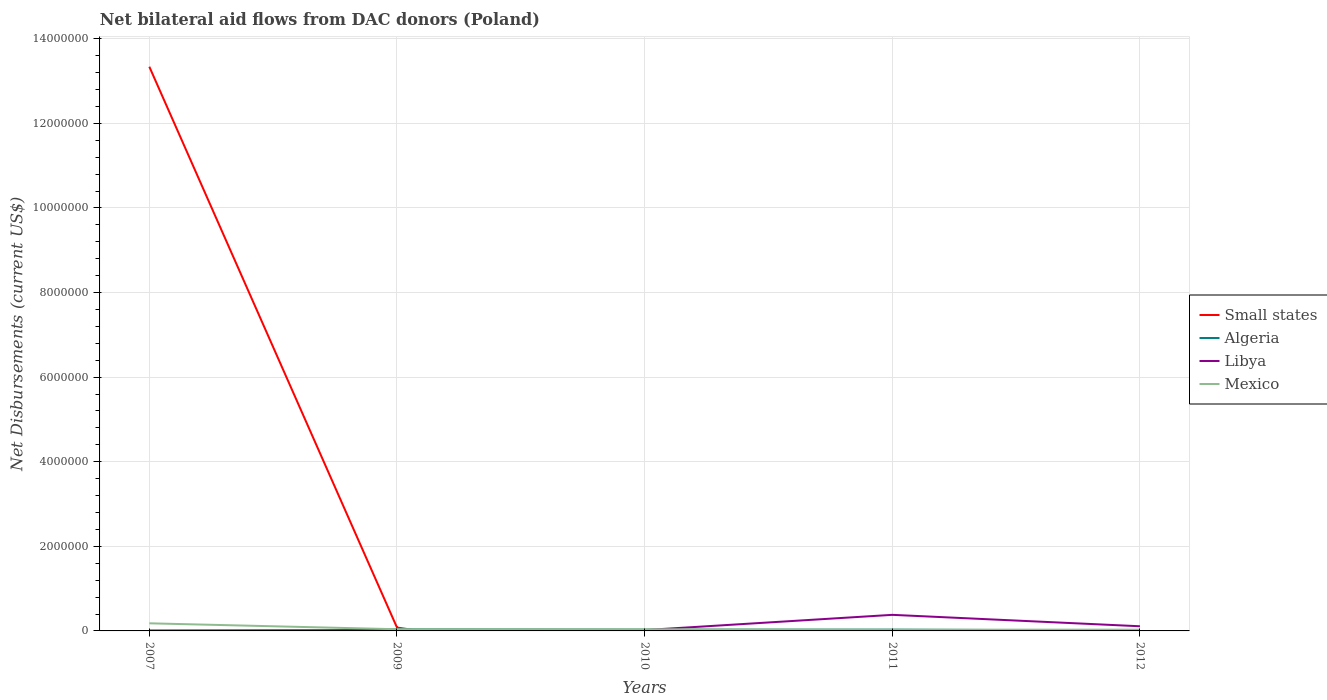How many different coloured lines are there?
Make the answer very short. 4. Does the line corresponding to Mexico intersect with the line corresponding to Algeria?
Your response must be concise. Yes. Is the number of lines equal to the number of legend labels?
Keep it short and to the point. No. Across all years, what is the maximum net bilateral aid flows in Algeria?
Your response must be concise. 0. What is the total net bilateral aid flows in Mexico in the graph?
Offer a very short reply. 0. What is the difference between the highest and the second highest net bilateral aid flows in Mexico?
Ensure brevity in your answer.  1.50e+05. How many lines are there?
Your answer should be compact. 4. What is the difference between two consecutive major ticks on the Y-axis?
Your answer should be very brief. 2.00e+06. Does the graph contain grids?
Your response must be concise. Yes. How many legend labels are there?
Provide a short and direct response. 4. What is the title of the graph?
Your response must be concise. Net bilateral aid flows from DAC donors (Poland). What is the label or title of the X-axis?
Make the answer very short. Years. What is the label or title of the Y-axis?
Ensure brevity in your answer.  Net Disbursements (current US$). What is the Net Disbursements (current US$) in Small states in 2007?
Your answer should be very brief. 1.33e+07. What is the Net Disbursements (current US$) in Algeria in 2007?
Make the answer very short. 0. What is the Net Disbursements (current US$) in Libya in 2007?
Offer a very short reply. 10000. What is the Net Disbursements (current US$) in Libya in 2009?
Your answer should be very brief. 2.00e+04. What is the Net Disbursements (current US$) of Mexico in 2009?
Offer a very short reply. 4.00e+04. What is the Net Disbursements (current US$) in Algeria in 2010?
Give a very brief answer. 3.00e+04. What is the Net Disbursements (current US$) in Libya in 2011?
Offer a terse response. 3.80e+05. What is the Net Disbursements (current US$) of Small states in 2012?
Provide a short and direct response. 0. What is the Net Disbursements (current US$) of Libya in 2012?
Your answer should be very brief. 1.10e+05. Across all years, what is the maximum Net Disbursements (current US$) in Small states?
Your answer should be very brief. 1.33e+07. Across all years, what is the minimum Net Disbursements (current US$) in Algeria?
Make the answer very short. 0. Across all years, what is the minimum Net Disbursements (current US$) in Mexico?
Keep it short and to the point. 3.00e+04. What is the total Net Disbursements (current US$) of Small states in the graph?
Offer a very short reply. 1.34e+07. What is the total Net Disbursements (current US$) of Libya in the graph?
Make the answer very short. 5.40e+05. What is the difference between the Net Disbursements (current US$) in Small states in 2007 and that in 2009?
Ensure brevity in your answer.  1.33e+07. What is the difference between the Net Disbursements (current US$) of Libya in 2007 and that in 2010?
Provide a short and direct response. -10000. What is the difference between the Net Disbursements (current US$) in Mexico in 2007 and that in 2010?
Ensure brevity in your answer.  1.40e+05. What is the difference between the Net Disbursements (current US$) in Libya in 2007 and that in 2011?
Give a very brief answer. -3.70e+05. What is the difference between the Net Disbursements (current US$) of Mexico in 2007 and that in 2012?
Provide a short and direct response. 1.50e+05. What is the difference between the Net Disbursements (current US$) in Algeria in 2009 and that in 2010?
Offer a terse response. 10000. What is the difference between the Net Disbursements (current US$) in Mexico in 2009 and that in 2010?
Give a very brief answer. 0. What is the difference between the Net Disbursements (current US$) in Libya in 2009 and that in 2011?
Ensure brevity in your answer.  -3.60e+05. What is the difference between the Net Disbursements (current US$) in Algeria in 2009 and that in 2012?
Provide a short and direct response. 3.00e+04. What is the difference between the Net Disbursements (current US$) in Libya in 2009 and that in 2012?
Ensure brevity in your answer.  -9.00e+04. What is the difference between the Net Disbursements (current US$) of Mexico in 2009 and that in 2012?
Provide a succinct answer. 10000. What is the difference between the Net Disbursements (current US$) of Algeria in 2010 and that in 2011?
Offer a terse response. 0. What is the difference between the Net Disbursements (current US$) of Libya in 2010 and that in 2011?
Ensure brevity in your answer.  -3.60e+05. What is the difference between the Net Disbursements (current US$) in Mexico in 2011 and that in 2012?
Your response must be concise. 0. What is the difference between the Net Disbursements (current US$) in Small states in 2007 and the Net Disbursements (current US$) in Algeria in 2009?
Offer a terse response. 1.33e+07. What is the difference between the Net Disbursements (current US$) in Small states in 2007 and the Net Disbursements (current US$) in Libya in 2009?
Provide a succinct answer. 1.33e+07. What is the difference between the Net Disbursements (current US$) of Small states in 2007 and the Net Disbursements (current US$) of Mexico in 2009?
Provide a succinct answer. 1.33e+07. What is the difference between the Net Disbursements (current US$) in Small states in 2007 and the Net Disbursements (current US$) in Algeria in 2010?
Provide a short and direct response. 1.33e+07. What is the difference between the Net Disbursements (current US$) of Small states in 2007 and the Net Disbursements (current US$) of Libya in 2010?
Ensure brevity in your answer.  1.33e+07. What is the difference between the Net Disbursements (current US$) of Small states in 2007 and the Net Disbursements (current US$) of Mexico in 2010?
Offer a terse response. 1.33e+07. What is the difference between the Net Disbursements (current US$) of Libya in 2007 and the Net Disbursements (current US$) of Mexico in 2010?
Your response must be concise. -3.00e+04. What is the difference between the Net Disbursements (current US$) of Small states in 2007 and the Net Disbursements (current US$) of Algeria in 2011?
Your answer should be very brief. 1.33e+07. What is the difference between the Net Disbursements (current US$) in Small states in 2007 and the Net Disbursements (current US$) in Libya in 2011?
Ensure brevity in your answer.  1.30e+07. What is the difference between the Net Disbursements (current US$) in Small states in 2007 and the Net Disbursements (current US$) in Mexico in 2011?
Your answer should be compact. 1.33e+07. What is the difference between the Net Disbursements (current US$) of Libya in 2007 and the Net Disbursements (current US$) of Mexico in 2011?
Your response must be concise. -2.00e+04. What is the difference between the Net Disbursements (current US$) in Small states in 2007 and the Net Disbursements (current US$) in Algeria in 2012?
Your response must be concise. 1.33e+07. What is the difference between the Net Disbursements (current US$) in Small states in 2007 and the Net Disbursements (current US$) in Libya in 2012?
Offer a very short reply. 1.32e+07. What is the difference between the Net Disbursements (current US$) in Small states in 2007 and the Net Disbursements (current US$) in Mexico in 2012?
Ensure brevity in your answer.  1.33e+07. What is the difference between the Net Disbursements (current US$) of Small states in 2009 and the Net Disbursements (current US$) of Mexico in 2010?
Offer a very short reply. 4.00e+04. What is the difference between the Net Disbursements (current US$) in Small states in 2009 and the Net Disbursements (current US$) in Algeria in 2011?
Ensure brevity in your answer.  5.00e+04. What is the difference between the Net Disbursements (current US$) of Small states in 2009 and the Net Disbursements (current US$) of Mexico in 2011?
Offer a very short reply. 5.00e+04. What is the difference between the Net Disbursements (current US$) of Small states in 2009 and the Net Disbursements (current US$) of Algeria in 2012?
Provide a succinct answer. 7.00e+04. What is the difference between the Net Disbursements (current US$) in Small states in 2009 and the Net Disbursements (current US$) in Libya in 2012?
Your answer should be very brief. -3.00e+04. What is the difference between the Net Disbursements (current US$) in Algeria in 2009 and the Net Disbursements (current US$) in Libya in 2012?
Ensure brevity in your answer.  -7.00e+04. What is the difference between the Net Disbursements (current US$) in Libya in 2009 and the Net Disbursements (current US$) in Mexico in 2012?
Provide a short and direct response. -10000. What is the difference between the Net Disbursements (current US$) of Algeria in 2010 and the Net Disbursements (current US$) of Libya in 2011?
Offer a terse response. -3.50e+05. What is the difference between the Net Disbursements (current US$) of Libya in 2010 and the Net Disbursements (current US$) of Mexico in 2011?
Your answer should be compact. -10000. What is the difference between the Net Disbursements (current US$) in Libya in 2010 and the Net Disbursements (current US$) in Mexico in 2012?
Offer a terse response. -10000. What is the difference between the Net Disbursements (current US$) of Algeria in 2011 and the Net Disbursements (current US$) of Libya in 2012?
Your answer should be compact. -8.00e+04. What is the difference between the Net Disbursements (current US$) in Algeria in 2011 and the Net Disbursements (current US$) in Mexico in 2012?
Your answer should be compact. 0. What is the difference between the Net Disbursements (current US$) of Libya in 2011 and the Net Disbursements (current US$) of Mexico in 2012?
Ensure brevity in your answer.  3.50e+05. What is the average Net Disbursements (current US$) in Small states per year?
Your answer should be very brief. 2.68e+06. What is the average Net Disbursements (current US$) in Algeria per year?
Make the answer very short. 2.20e+04. What is the average Net Disbursements (current US$) in Libya per year?
Make the answer very short. 1.08e+05. What is the average Net Disbursements (current US$) in Mexico per year?
Your answer should be compact. 6.40e+04. In the year 2007, what is the difference between the Net Disbursements (current US$) in Small states and Net Disbursements (current US$) in Libya?
Offer a very short reply. 1.33e+07. In the year 2007, what is the difference between the Net Disbursements (current US$) of Small states and Net Disbursements (current US$) of Mexico?
Your answer should be very brief. 1.32e+07. In the year 2007, what is the difference between the Net Disbursements (current US$) of Libya and Net Disbursements (current US$) of Mexico?
Make the answer very short. -1.70e+05. In the year 2009, what is the difference between the Net Disbursements (current US$) in Small states and Net Disbursements (current US$) in Libya?
Your answer should be very brief. 6.00e+04. In the year 2009, what is the difference between the Net Disbursements (current US$) in Small states and Net Disbursements (current US$) in Mexico?
Offer a terse response. 4.00e+04. In the year 2009, what is the difference between the Net Disbursements (current US$) in Algeria and Net Disbursements (current US$) in Libya?
Offer a very short reply. 2.00e+04. In the year 2009, what is the difference between the Net Disbursements (current US$) of Libya and Net Disbursements (current US$) of Mexico?
Make the answer very short. -2.00e+04. In the year 2010, what is the difference between the Net Disbursements (current US$) in Algeria and Net Disbursements (current US$) in Libya?
Give a very brief answer. 10000. In the year 2011, what is the difference between the Net Disbursements (current US$) of Algeria and Net Disbursements (current US$) of Libya?
Keep it short and to the point. -3.50e+05. What is the ratio of the Net Disbursements (current US$) in Small states in 2007 to that in 2009?
Make the answer very short. 166.75. What is the ratio of the Net Disbursements (current US$) of Mexico in 2007 to that in 2009?
Offer a very short reply. 4.5. What is the ratio of the Net Disbursements (current US$) of Mexico in 2007 to that in 2010?
Ensure brevity in your answer.  4.5. What is the ratio of the Net Disbursements (current US$) in Libya in 2007 to that in 2011?
Your answer should be compact. 0.03. What is the ratio of the Net Disbursements (current US$) of Mexico in 2007 to that in 2011?
Offer a very short reply. 6. What is the ratio of the Net Disbursements (current US$) of Libya in 2007 to that in 2012?
Ensure brevity in your answer.  0.09. What is the ratio of the Net Disbursements (current US$) in Algeria in 2009 to that in 2010?
Offer a terse response. 1.33. What is the ratio of the Net Disbursements (current US$) of Libya in 2009 to that in 2010?
Your answer should be compact. 1. What is the ratio of the Net Disbursements (current US$) in Libya in 2009 to that in 2011?
Your response must be concise. 0.05. What is the ratio of the Net Disbursements (current US$) in Mexico in 2009 to that in 2011?
Your answer should be very brief. 1.33. What is the ratio of the Net Disbursements (current US$) in Libya in 2009 to that in 2012?
Ensure brevity in your answer.  0.18. What is the ratio of the Net Disbursements (current US$) of Mexico in 2009 to that in 2012?
Provide a short and direct response. 1.33. What is the ratio of the Net Disbursements (current US$) in Algeria in 2010 to that in 2011?
Your answer should be compact. 1. What is the ratio of the Net Disbursements (current US$) of Libya in 2010 to that in 2011?
Keep it short and to the point. 0.05. What is the ratio of the Net Disbursements (current US$) of Mexico in 2010 to that in 2011?
Your answer should be compact. 1.33. What is the ratio of the Net Disbursements (current US$) in Libya in 2010 to that in 2012?
Provide a short and direct response. 0.18. What is the ratio of the Net Disbursements (current US$) in Algeria in 2011 to that in 2012?
Your response must be concise. 3. What is the ratio of the Net Disbursements (current US$) in Libya in 2011 to that in 2012?
Make the answer very short. 3.45. What is the ratio of the Net Disbursements (current US$) of Mexico in 2011 to that in 2012?
Offer a terse response. 1. What is the difference between the highest and the second highest Net Disbursements (current US$) of Algeria?
Provide a short and direct response. 10000. What is the difference between the highest and the second highest Net Disbursements (current US$) in Libya?
Provide a short and direct response. 2.70e+05. What is the difference between the highest and the lowest Net Disbursements (current US$) of Small states?
Provide a short and direct response. 1.33e+07. What is the difference between the highest and the lowest Net Disbursements (current US$) of Algeria?
Your answer should be compact. 4.00e+04. What is the difference between the highest and the lowest Net Disbursements (current US$) of Libya?
Make the answer very short. 3.70e+05. What is the difference between the highest and the lowest Net Disbursements (current US$) in Mexico?
Provide a short and direct response. 1.50e+05. 